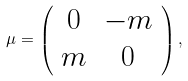<formula> <loc_0><loc_0><loc_500><loc_500>\mu = \left ( \begin{array} { c c } 0 & - m \\ m & 0 \end{array} \right ) ,</formula> 